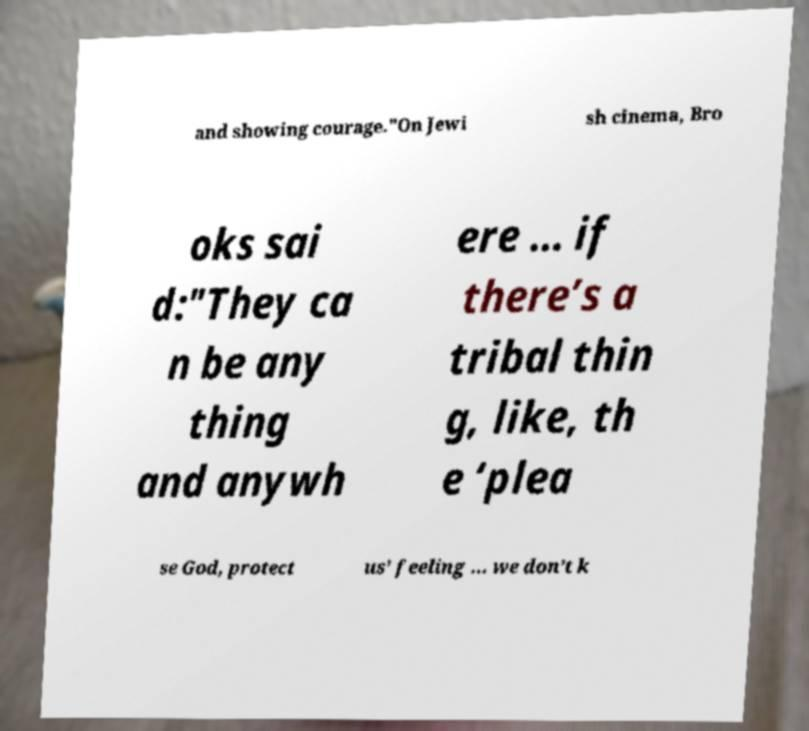Can you read and provide the text displayed in the image?This photo seems to have some interesting text. Can you extract and type it out for me? and showing courage."On Jewi sh cinema, Bro oks sai d:"They ca n be any thing and anywh ere … if there’s a tribal thin g, like, th e ‘plea se God, protect us’ feeling … we don’t k 